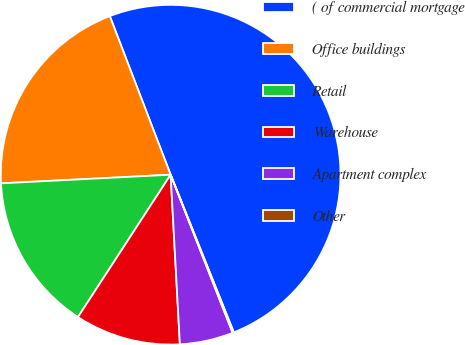Convert chart. <chart><loc_0><loc_0><loc_500><loc_500><pie_chart><fcel>( of commercial mortgage<fcel>Office buildings<fcel>Retail<fcel>Warehouse<fcel>Apartment complex<fcel>Other<nl><fcel>49.76%<fcel>19.98%<fcel>15.01%<fcel>10.05%<fcel>5.08%<fcel>0.12%<nl></chart> 